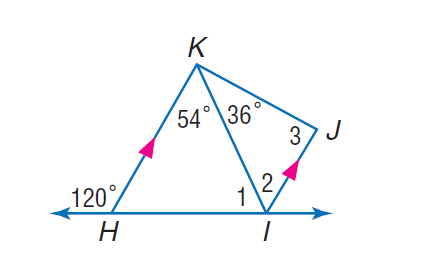Answer the mathemtical geometry problem and directly provide the correct option letter.
Question: If K H is parallel to J I, find the measure of \angle 3.
Choices: A: 36 B: 60 C: 90 D: 120 C 